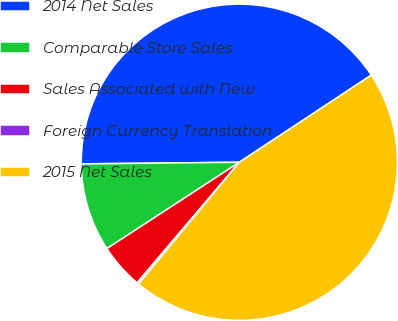Convert chart to OTSL. <chart><loc_0><loc_0><loc_500><loc_500><pie_chart><fcel>2014 Net Sales<fcel>Comparable Store Sales<fcel>Sales Associated with New<fcel>Foreign Currency Translation<fcel>2015 Net Sales<nl><fcel>40.88%<fcel>9.03%<fcel>4.61%<fcel>0.19%<fcel>45.3%<nl></chart> 